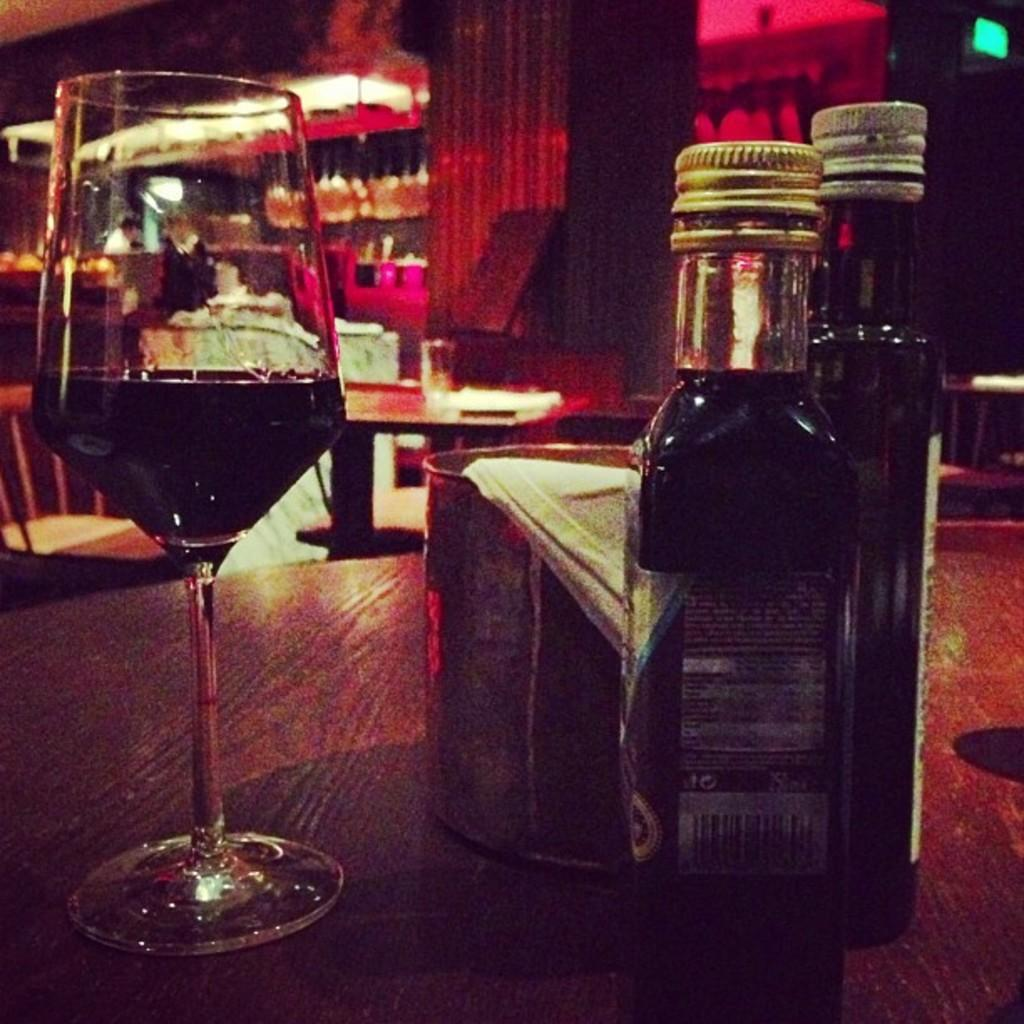What objects are on the table in the image? There are bottles, a container, and a glass on the table in the image. What type of furniture is visible in the image? There are chairs and tables visible in the image. How many tables are visible in the image? There is at least one table visible in the image. What type of muscle development can be seen in the image? There is no muscle development visible in the image; it features objects on a table and furniture. 